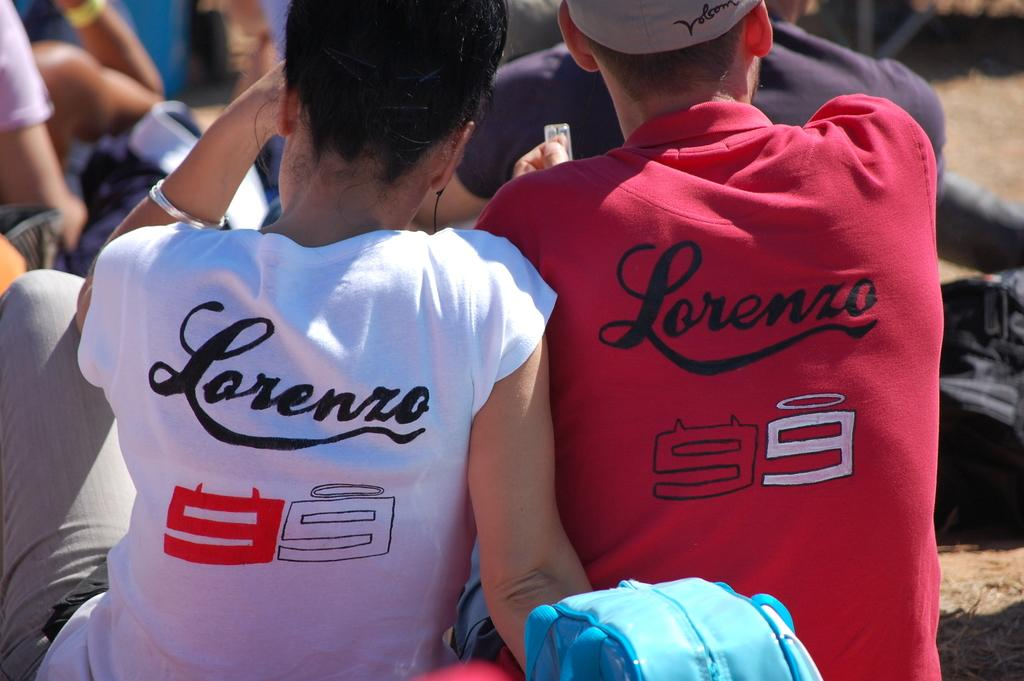<image>
Summarize the visual content of the image. TWO PEOPLE WEARING SHIRTS THAT SAY LORENZO 99 